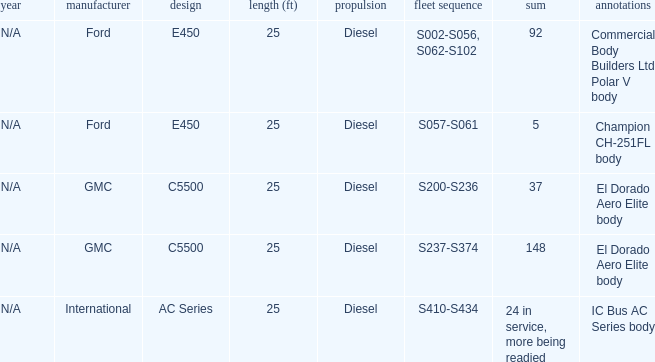Which model with a fleet series of s410-s434? AC Series. 